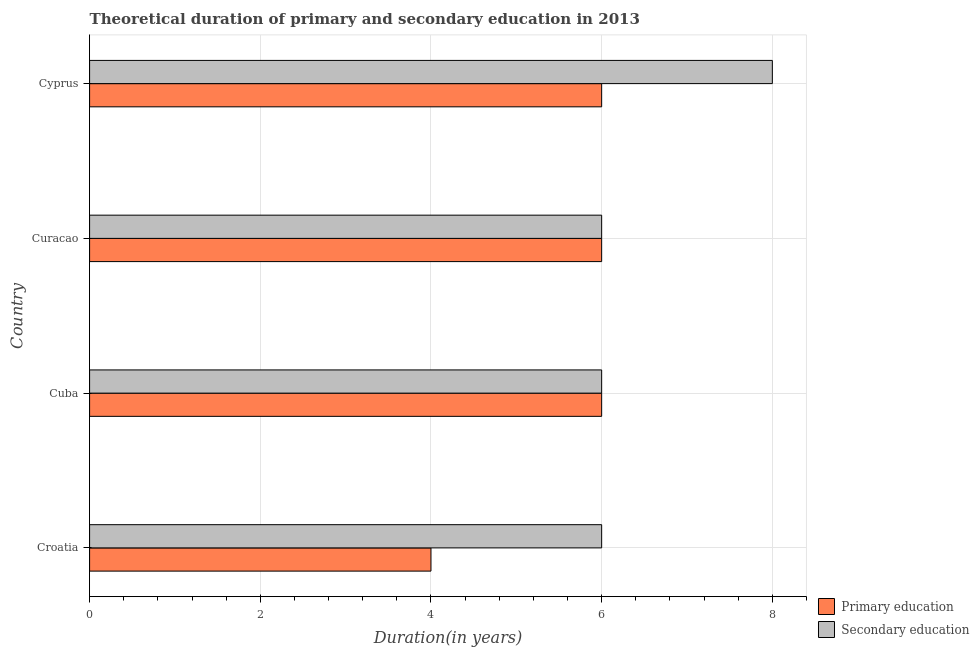How many different coloured bars are there?
Your response must be concise. 2. How many groups of bars are there?
Keep it short and to the point. 4. Are the number of bars per tick equal to the number of legend labels?
Offer a terse response. Yes. Are the number of bars on each tick of the Y-axis equal?
Your response must be concise. Yes. How many bars are there on the 1st tick from the top?
Make the answer very short. 2. What is the label of the 3rd group of bars from the top?
Your answer should be compact. Cuba. In how many cases, is the number of bars for a given country not equal to the number of legend labels?
Make the answer very short. 0. In which country was the duration of primary education maximum?
Your answer should be compact. Cuba. In which country was the duration of secondary education minimum?
Keep it short and to the point. Croatia. What is the total duration of primary education in the graph?
Your answer should be compact. 22. What is the difference between the duration of primary education in Croatia and that in Curacao?
Ensure brevity in your answer.  -2. What is the difference between the duration of secondary education in Croatia and the duration of primary education in Curacao?
Your response must be concise. 0. What is the average duration of primary education per country?
Offer a terse response. 5.5. What is the ratio of the duration of primary education in Croatia to that in Cuba?
Offer a very short reply. 0.67. Is the duration of primary education in Croatia less than that in Cuba?
Your answer should be very brief. Yes. What is the difference between the highest and the lowest duration of primary education?
Your response must be concise. 2. What does the 1st bar from the top in Cuba represents?
Your response must be concise. Secondary education. Are all the bars in the graph horizontal?
Provide a succinct answer. Yes. What is the difference between two consecutive major ticks on the X-axis?
Your response must be concise. 2. Are the values on the major ticks of X-axis written in scientific E-notation?
Your answer should be compact. No. Does the graph contain any zero values?
Provide a succinct answer. No. Does the graph contain grids?
Offer a terse response. Yes. Where does the legend appear in the graph?
Your answer should be compact. Bottom right. What is the title of the graph?
Give a very brief answer. Theoretical duration of primary and secondary education in 2013. Does "Females" appear as one of the legend labels in the graph?
Give a very brief answer. No. What is the label or title of the X-axis?
Provide a succinct answer. Duration(in years). What is the label or title of the Y-axis?
Offer a very short reply. Country. What is the Duration(in years) in Secondary education in Croatia?
Give a very brief answer. 6. What is the Duration(in years) of Secondary education in Cuba?
Offer a very short reply. 6. What is the Duration(in years) of Secondary education in Curacao?
Offer a terse response. 6. What is the Duration(in years) in Secondary education in Cyprus?
Provide a short and direct response. 8. Across all countries, what is the maximum Duration(in years) in Secondary education?
Your answer should be compact. 8. Across all countries, what is the minimum Duration(in years) of Primary education?
Keep it short and to the point. 4. Across all countries, what is the minimum Duration(in years) of Secondary education?
Your answer should be compact. 6. What is the total Duration(in years) in Secondary education in the graph?
Your response must be concise. 26. What is the difference between the Duration(in years) in Primary education in Croatia and that in Cuba?
Provide a succinct answer. -2. What is the difference between the Duration(in years) in Secondary education in Croatia and that in Cuba?
Make the answer very short. 0. What is the difference between the Duration(in years) of Primary education in Croatia and that in Curacao?
Provide a succinct answer. -2. What is the difference between the Duration(in years) of Secondary education in Cuba and that in Curacao?
Provide a succinct answer. 0. What is the difference between the Duration(in years) of Primary education in Cuba and that in Cyprus?
Give a very brief answer. 0. What is the difference between the Duration(in years) of Primary education in Curacao and that in Cyprus?
Offer a terse response. 0. What is the difference between the Duration(in years) of Secondary education in Curacao and that in Cyprus?
Offer a terse response. -2. What is the difference between the Duration(in years) of Primary education in Cuba and the Duration(in years) of Secondary education in Curacao?
Offer a terse response. 0. What is the difference between the Duration(in years) in Primary education in Cuba and the Duration(in years) in Secondary education in Cyprus?
Your response must be concise. -2. What is the average Duration(in years) in Primary education per country?
Provide a succinct answer. 5.5. What is the average Duration(in years) of Secondary education per country?
Provide a succinct answer. 6.5. What is the difference between the Duration(in years) in Primary education and Duration(in years) in Secondary education in Croatia?
Offer a very short reply. -2. What is the ratio of the Duration(in years) of Primary education in Croatia to that in Cuba?
Your answer should be very brief. 0.67. What is the ratio of the Duration(in years) of Secondary education in Croatia to that in Cuba?
Make the answer very short. 1. What is the ratio of the Duration(in years) of Primary education in Cuba to that in Curacao?
Ensure brevity in your answer.  1. What is the ratio of the Duration(in years) in Secondary education in Cuba to that in Curacao?
Your response must be concise. 1. What is the ratio of the Duration(in years) of Primary education in Cuba to that in Cyprus?
Your answer should be compact. 1. What is the ratio of the Duration(in years) of Secondary education in Cuba to that in Cyprus?
Make the answer very short. 0.75. What is the ratio of the Duration(in years) in Primary education in Curacao to that in Cyprus?
Ensure brevity in your answer.  1. What is the ratio of the Duration(in years) of Secondary education in Curacao to that in Cyprus?
Provide a short and direct response. 0.75. What is the difference between the highest and the second highest Duration(in years) of Primary education?
Your answer should be very brief. 0. What is the difference between the highest and the lowest Duration(in years) in Primary education?
Give a very brief answer. 2. 